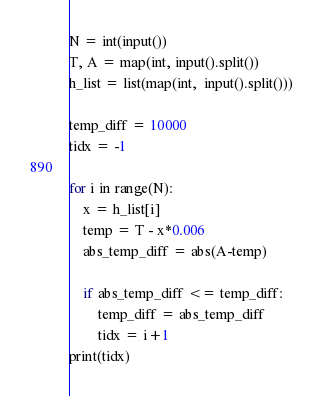<code> <loc_0><loc_0><loc_500><loc_500><_Python_>N = int(input())
T, A = map(int, input().split())
h_list = list(map(int,  input().split()))

temp_diff = 10000
tidx = -1

for i in range(N):
    x = h_list[i]
    temp = T - x*0.006
    abs_temp_diff = abs(A-temp)

    if abs_temp_diff <= temp_diff:
        temp_diff = abs_temp_diff
        tidx = i+1
print(tidx)
</code> 